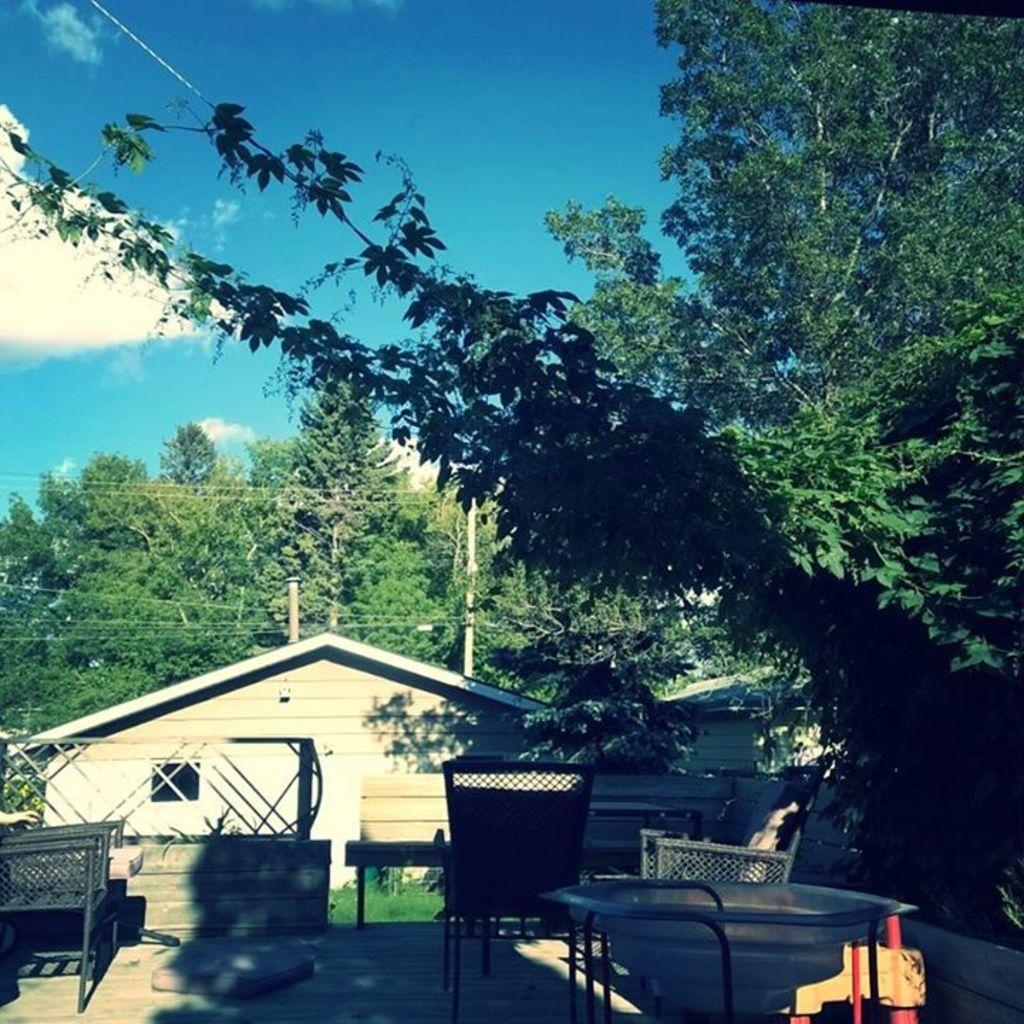What type of furniture is present in the image? There are tables and chairs in the image. What type of structure can be seen in the image? There is a wall in the image. What type of natural environment is visible in the image? There is grass in the image. What type of additional structures can be seen in the image? There are sheds in the image. What type of vertical supports are present in the image? There are poles in the image. What type of vegetation is visible in the image? There are trees in the image. What is visible in the background of the image? The sky is visible in the background of the image. What can be seen in the sky? There are clouds in the sky. What type of activity is the grass participating in during the afterthought? There is no activity or afterthought involving the grass in the image; it is simply a part of the natural environment. 